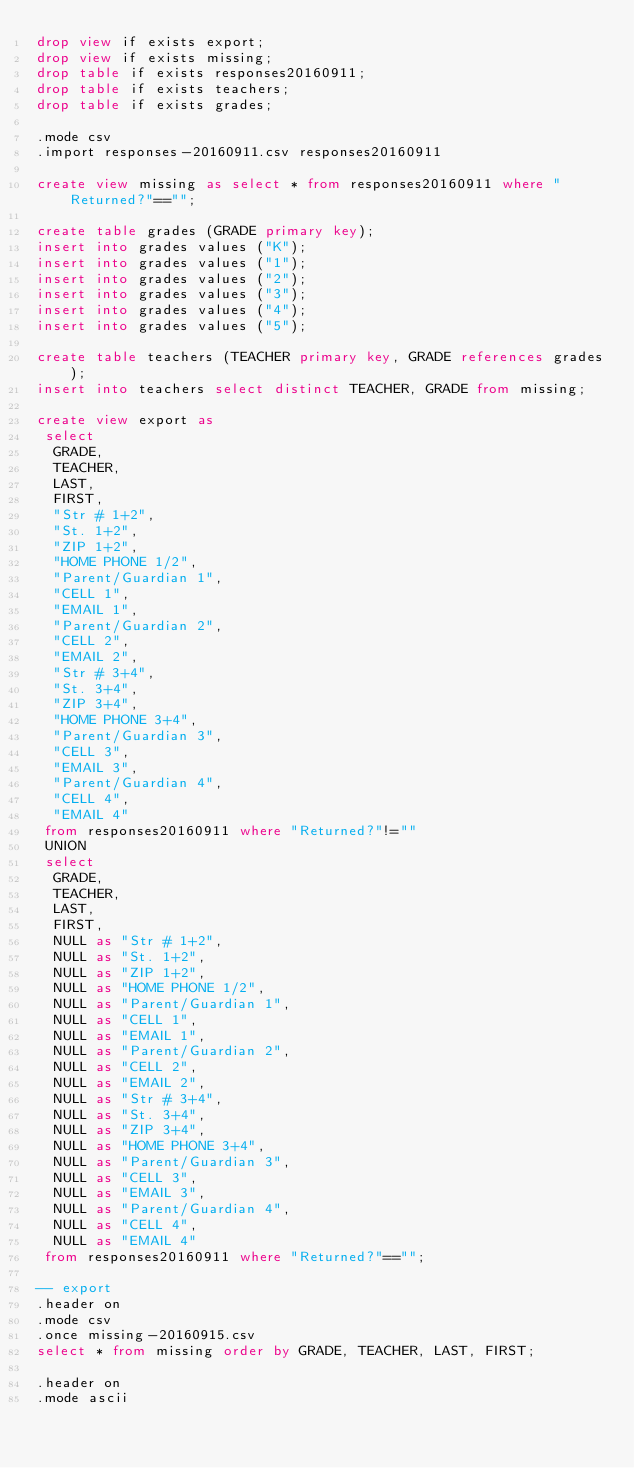Convert code to text. <code><loc_0><loc_0><loc_500><loc_500><_SQL_>drop view if exists export;
drop view if exists missing;
drop table if exists responses20160911;
drop table if exists teachers;
drop table if exists grades;

.mode csv
.import responses-20160911.csv responses20160911

create view missing as select * from responses20160911 where "Returned?"=="";

create table grades (GRADE primary key);
insert into grades values ("K");
insert into grades values ("1");
insert into grades values ("2");
insert into grades values ("3");
insert into grades values ("4");
insert into grades values ("5");

create table teachers (TEACHER primary key, GRADE references grades);
insert into teachers select distinct TEACHER, GRADE from missing;

create view export as
 select
  GRADE,
  TEACHER,
  LAST,
  FIRST,
  "Str # 1+2",
  "St. 1+2",
  "ZIP 1+2",
  "HOME PHONE 1/2",
  "Parent/Guardian 1",
  "CELL 1",
  "EMAIL 1",
  "Parent/Guardian 2",
  "CELL 2",
  "EMAIL 2",
  "Str # 3+4",
  "St. 3+4",
  "ZIP 3+4",
  "HOME PHONE 3+4",
  "Parent/Guardian 3",
  "CELL 3",
  "EMAIL 3",
  "Parent/Guardian 4",
  "CELL 4",
  "EMAIL 4"
 from responses20160911 where "Returned?"!=""
 UNION
 select
  GRADE,
  TEACHER,
  LAST,
  FIRST,
  NULL as "Str # 1+2",
  NULL as "St. 1+2",
  NULL as "ZIP 1+2",
  NULL as "HOME PHONE 1/2",
  NULL as "Parent/Guardian 1",
  NULL as "CELL 1",
  NULL as "EMAIL 1",
  NULL as "Parent/Guardian 2",
  NULL as "CELL 2",
  NULL as "EMAIL 2",
  NULL as "Str # 3+4",
  NULL as "St. 3+4",
  NULL as "ZIP 3+4",
  NULL as "HOME PHONE 3+4",
  NULL as "Parent/Guardian 3",
  NULL as "CELL 3",
  NULL as "EMAIL 3",
  NULL as "Parent/Guardian 4",
  NULL as "CELL 4",
  NULL as "EMAIL 4"
 from responses20160911 where "Returned?"=="";

-- export
.header on
.mode csv
.once missing-20160915.csv
select * from missing order by GRADE, TEACHER, LAST, FIRST;

.header on
.mode ascii</code> 